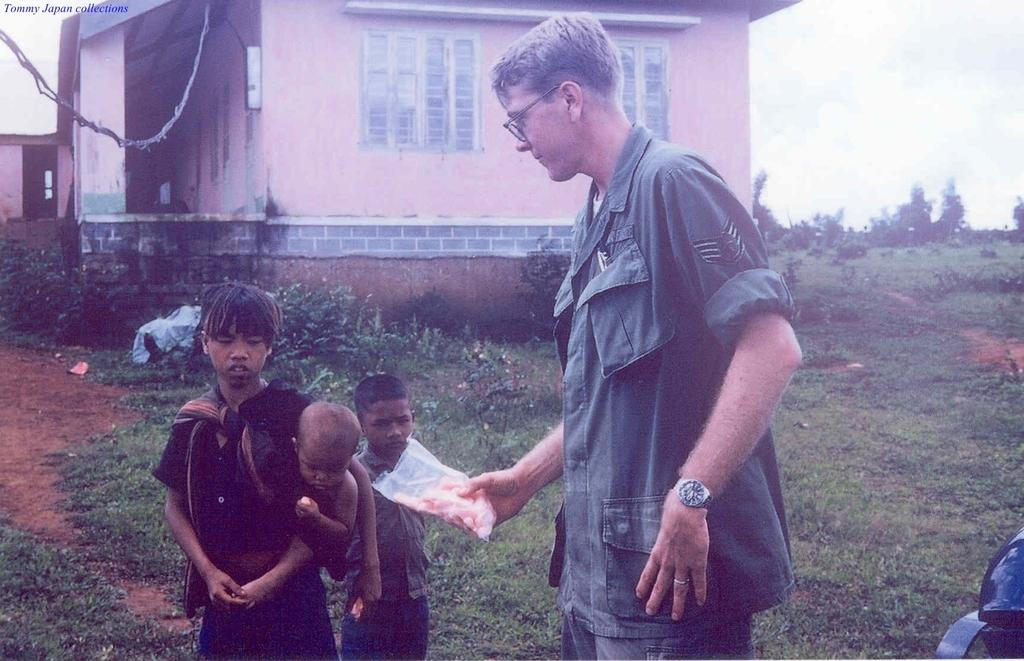What is the person holding in the image? The person is holding a packet in the image. What is the boy doing in the image? The boy is holding a kid in the image. How many kids are present in the image? There are two kids in the image. What type of structure can be seen in the image? There is a house in the image. What type of vegetation is visible in the image? There are trees and plants in the image. What type of lip can be seen on the house in the image? There is no lip present on the house in the image. What type of liquid is being poured by the person holding the packet in the image? There is no liquid being poured in the image; the person is simply holding a packet. 